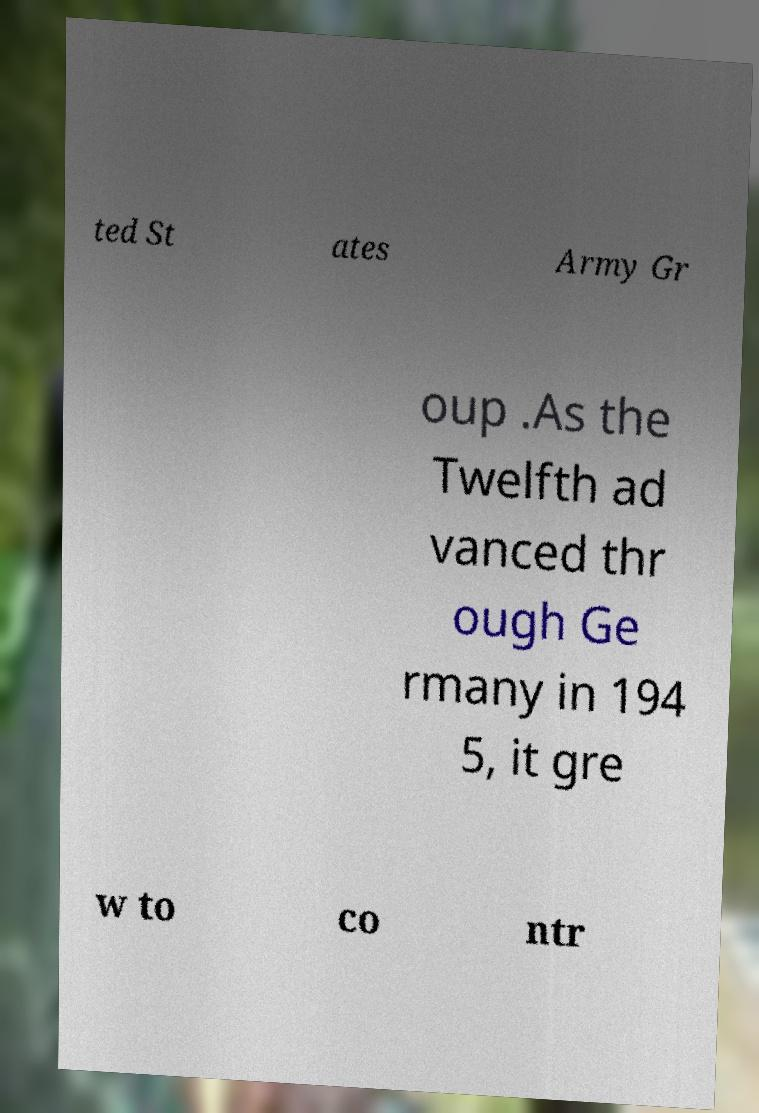Could you assist in decoding the text presented in this image and type it out clearly? ted St ates Army Gr oup .As the Twelfth ad vanced thr ough Ge rmany in 194 5, it gre w to co ntr 